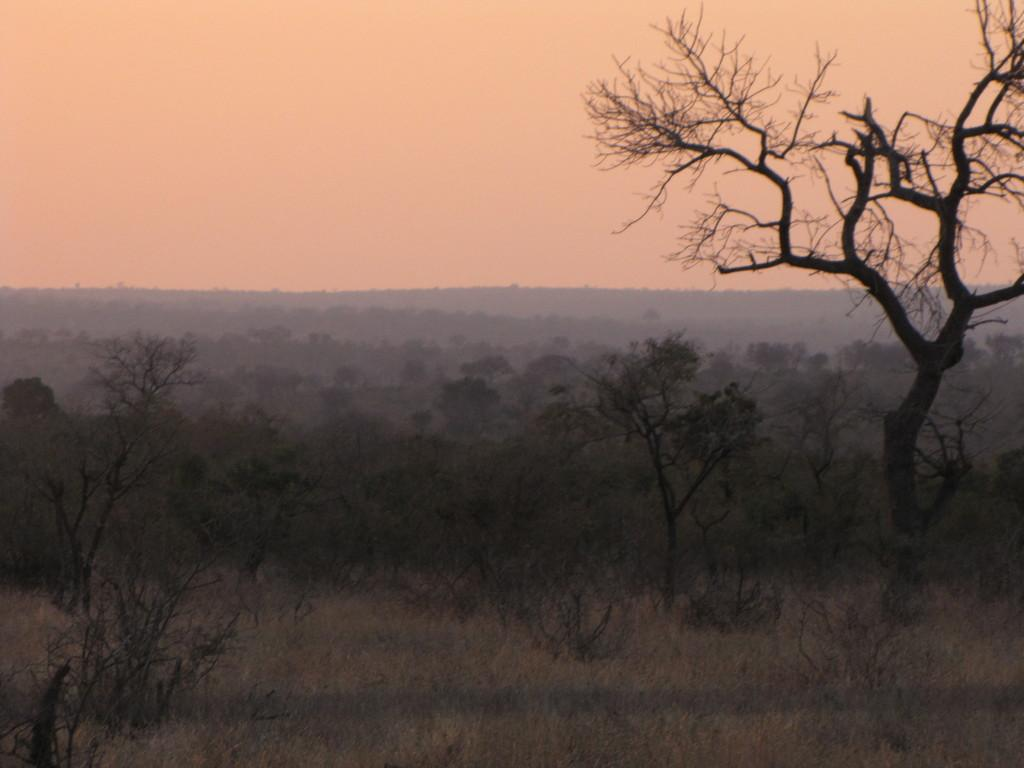What is located in the center of the image? There are trees in the center of the image. What can be seen in the background of the image? There are hills and the sky visible in the background of the image. What type of vegetation is at the bottom of the image? There is grass at the bottom of the image. Can you see your uncle's toes in the image? There is no reference to any person, including an uncle, in the image, so it is not possible to see anyone's toes. What type of destruction is visible in the image? There is no destruction present in the image; it features trees, hills, sky, and grass. 